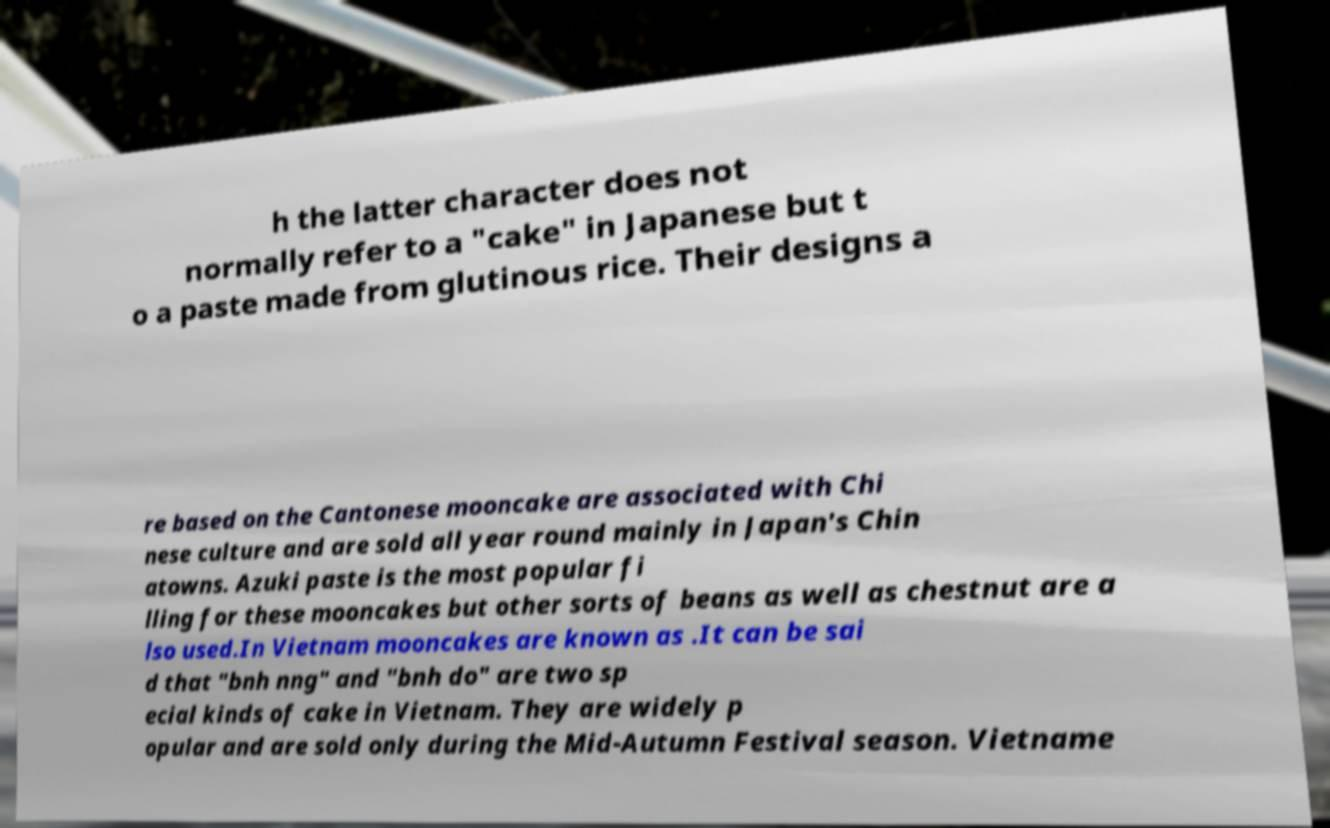For documentation purposes, I need the text within this image transcribed. Could you provide that? h the latter character does not normally refer to a "cake" in Japanese but t o a paste made from glutinous rice. Their designs a re based on the Cantonese mooncake are associated with Chi nese culture and are sold all year round mainly in Japan's Chin atowns. Azuki paste is the most popular fi lling for these mooncakes but other sorts of beans as well as chestnut are a lso used.In Vietnam mooncakes are known as .It can be sai d that "bnh nng" and "bnh do" are two sp ecial kinds of cake in Vietnam. They are widely p opular and are sold only during the Mid-Autumn Festival season. Vietname 